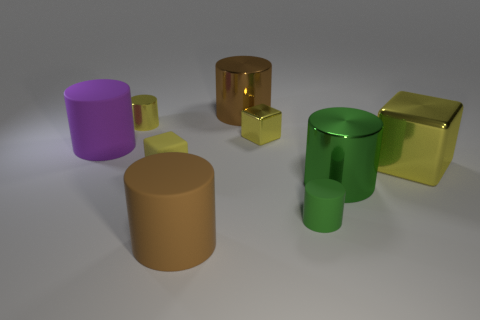Subtract all small cubes. How many cubes are left? 1 Subtract all purple cylinders. How many cylinders are left? 5 Subtract all brown cylinders. How many green cubes are left? 0 Subtract all small green cylinders. Subtract all tiny green shiny spheres. How many objects are left? 8 Add 5 large brown matte objects. How many large brown matte objects are left? 6 Add 2 big yellow objects. How many big yellow objects exist? 3 Add 1 tiny green blocks. How many objects exist? 10 Subtract 0 red cylinders. How many objects are left? 9 Subtract all blocks. How many objects are left? 6 Subtract 1 cubes. How many cubes are left? 2 